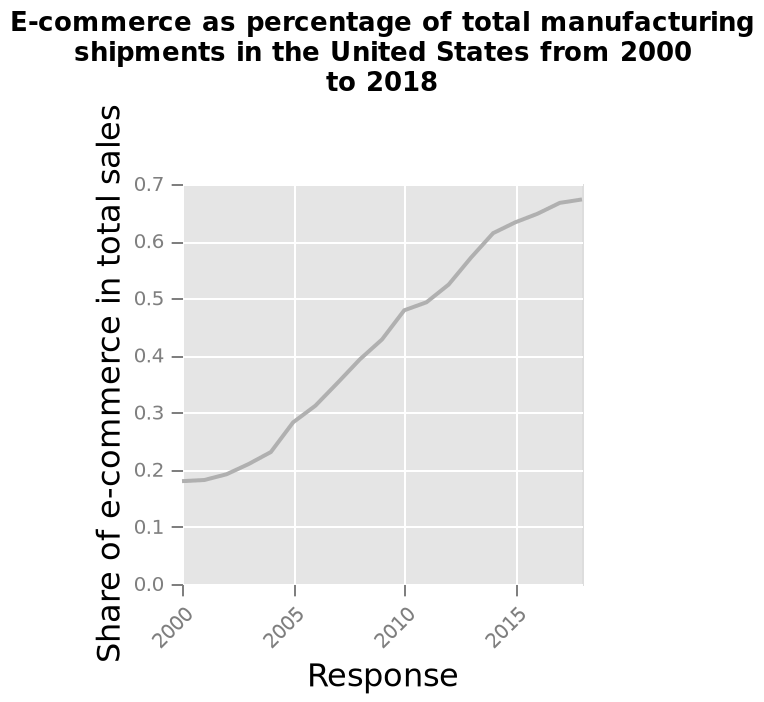<image>
What does the y-axis measure in the diagram? The y-axis measures the share of e-commerce in total sales, on a scale ranging from 0.0 to 0.7. What has been happening to the percentage share of e-commerce in US manufacturing between 2000 and 2018?  The percentage share of e-commerce in US manufacturing has been rising at a steady rate between 2000 and 2018. 